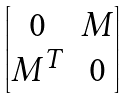<formula> <loc_0><loc_0><loc_500><loc_500>\begin{bmatrix} 0 & M \\ M ^ { T } & 0 \end{bmatrix}</formula> 